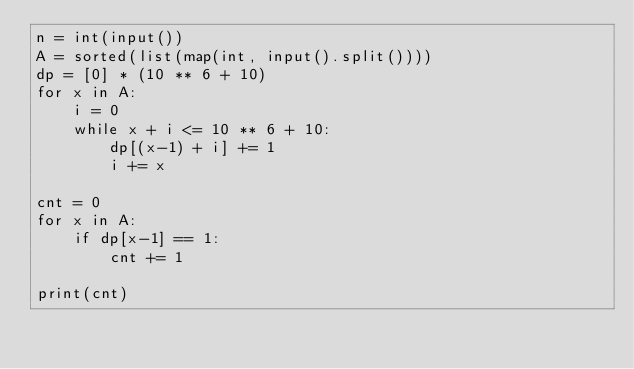<code> <loc_0><loc_0><loc_500><loc_500><_Python_>n = int(input())
A = sorted(list(map(int, input().split())))
dp = [0] * (10 ** 6 + 10)
for x in A:
    i = 0
    while x + i <= 10 ** 6 + 10:
        dp[(x-1) + i] += 1
        i += x

cnt = 0
for x in A:
    if dp[x-1] == 1:
        cnt += 1

print(cnt)</code> 